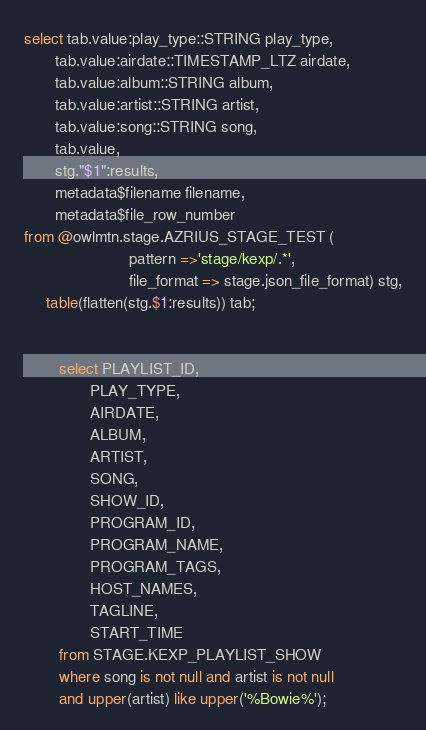Convert code to text. <code><loc_0><loc_0><loc_500><loc_500><_SQL_>select tab.value:play_type::STRING play_type,
       tab.value:airdate::TIMESTAMP_LTZ airdate,
       tab.value:album::STRING album,
       tab.value:artist::STRING artist,
       tab.value:song::STRING song,
       tab.value,
       stg."$1":results,
       metadata$filename filename,
       metadata$file_row_number
from @owlmtn.stage.AZRIUS_STAGE_TEST (
                        pattern =>'stage/kexp/.*',
                        file_format => stage.json_file_format) stg,
     table(flatten(stg.$1:results)) tab;


        select PLAYLIST_ID,
               PLAY_TYPE,
               AIRDATE,
               ALBUM,
               ARTIST,
               SONG,
               SHOW_ID,
               PROGRAM_ID,
               PROGRAM_NAME,
               PROGRAM_TAGS,
               HOST_NAMES,
               TAGLINE,
               START_TIME
        from STAGE.KEXP_PLAYLIST_SHOW
        where song is not null and artist is not null
        and upper(artist) like upper('%Bowie%');
</code> 